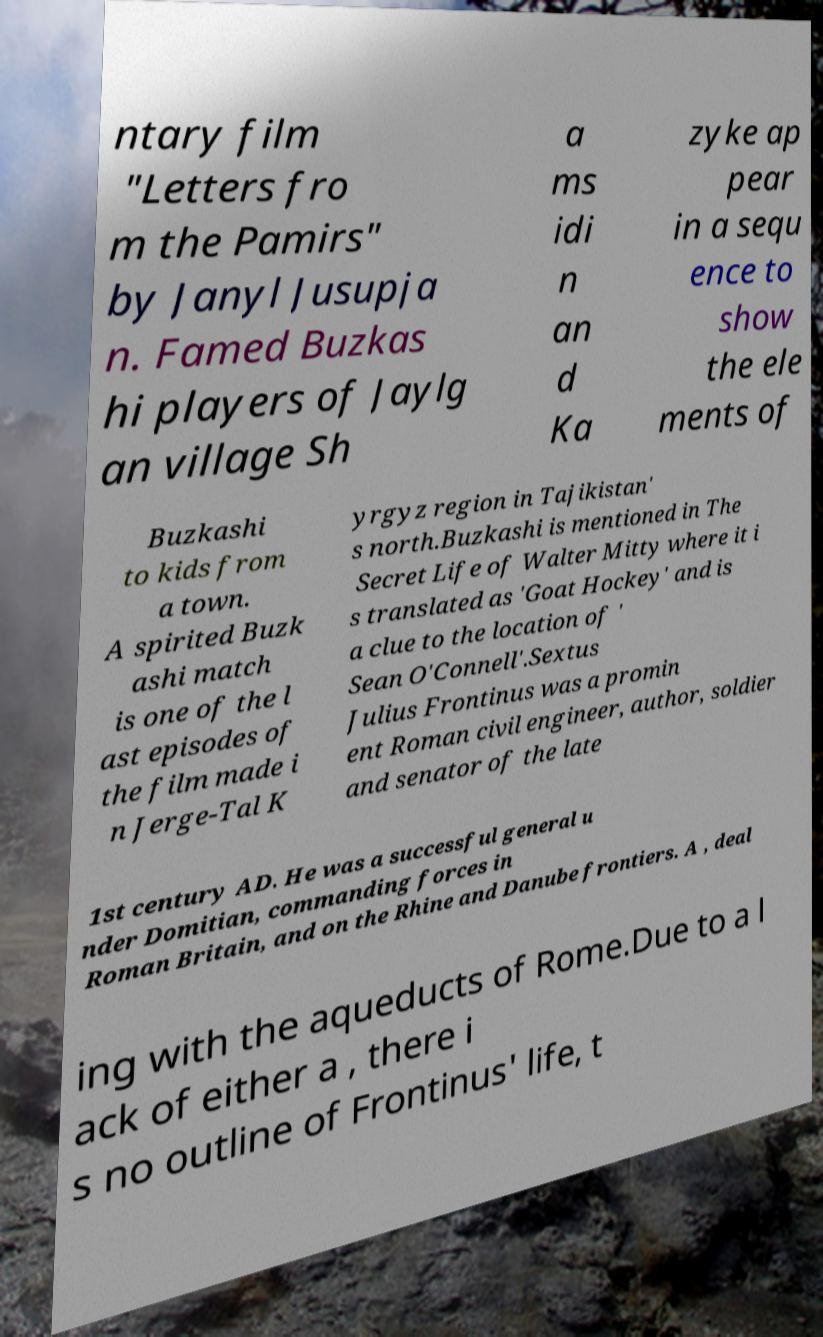For documentation purposes, I need the text within this image transcribed. Could you provide that? ntary film "Letters fro m the Pamirs" by Janyl Jusupja n. Famed Buzkas hi players of Jaylg an village Sh a ms idi n an d Ka zyke ap pear in a sequ ence to show the ele ments of Buzkashi to kids from a town. A spirited Buzk ashi match is one of the l ast episodes of the film made i n Jerge-Tal K yrgyz region in Tajikistan' s north.Buzkashi is mentioned in The Secret Life of Walter Mitty where it i s translated as 'Goat Hockey' and is a clue to the location of ' Sean O'Connell'.Sextus Julius Frontinus was a promin ent Roman civil engineer, author, soldier and senator of the late 1st century AD. He was a successful general u nder Domitian, commanding forces in Roman Britain, and on the Rhine and Danube frontiers. A , deal ing with the aqueducts of Rome.Due to a l ack of either a , there i s no outline of Frontinus' life, t 